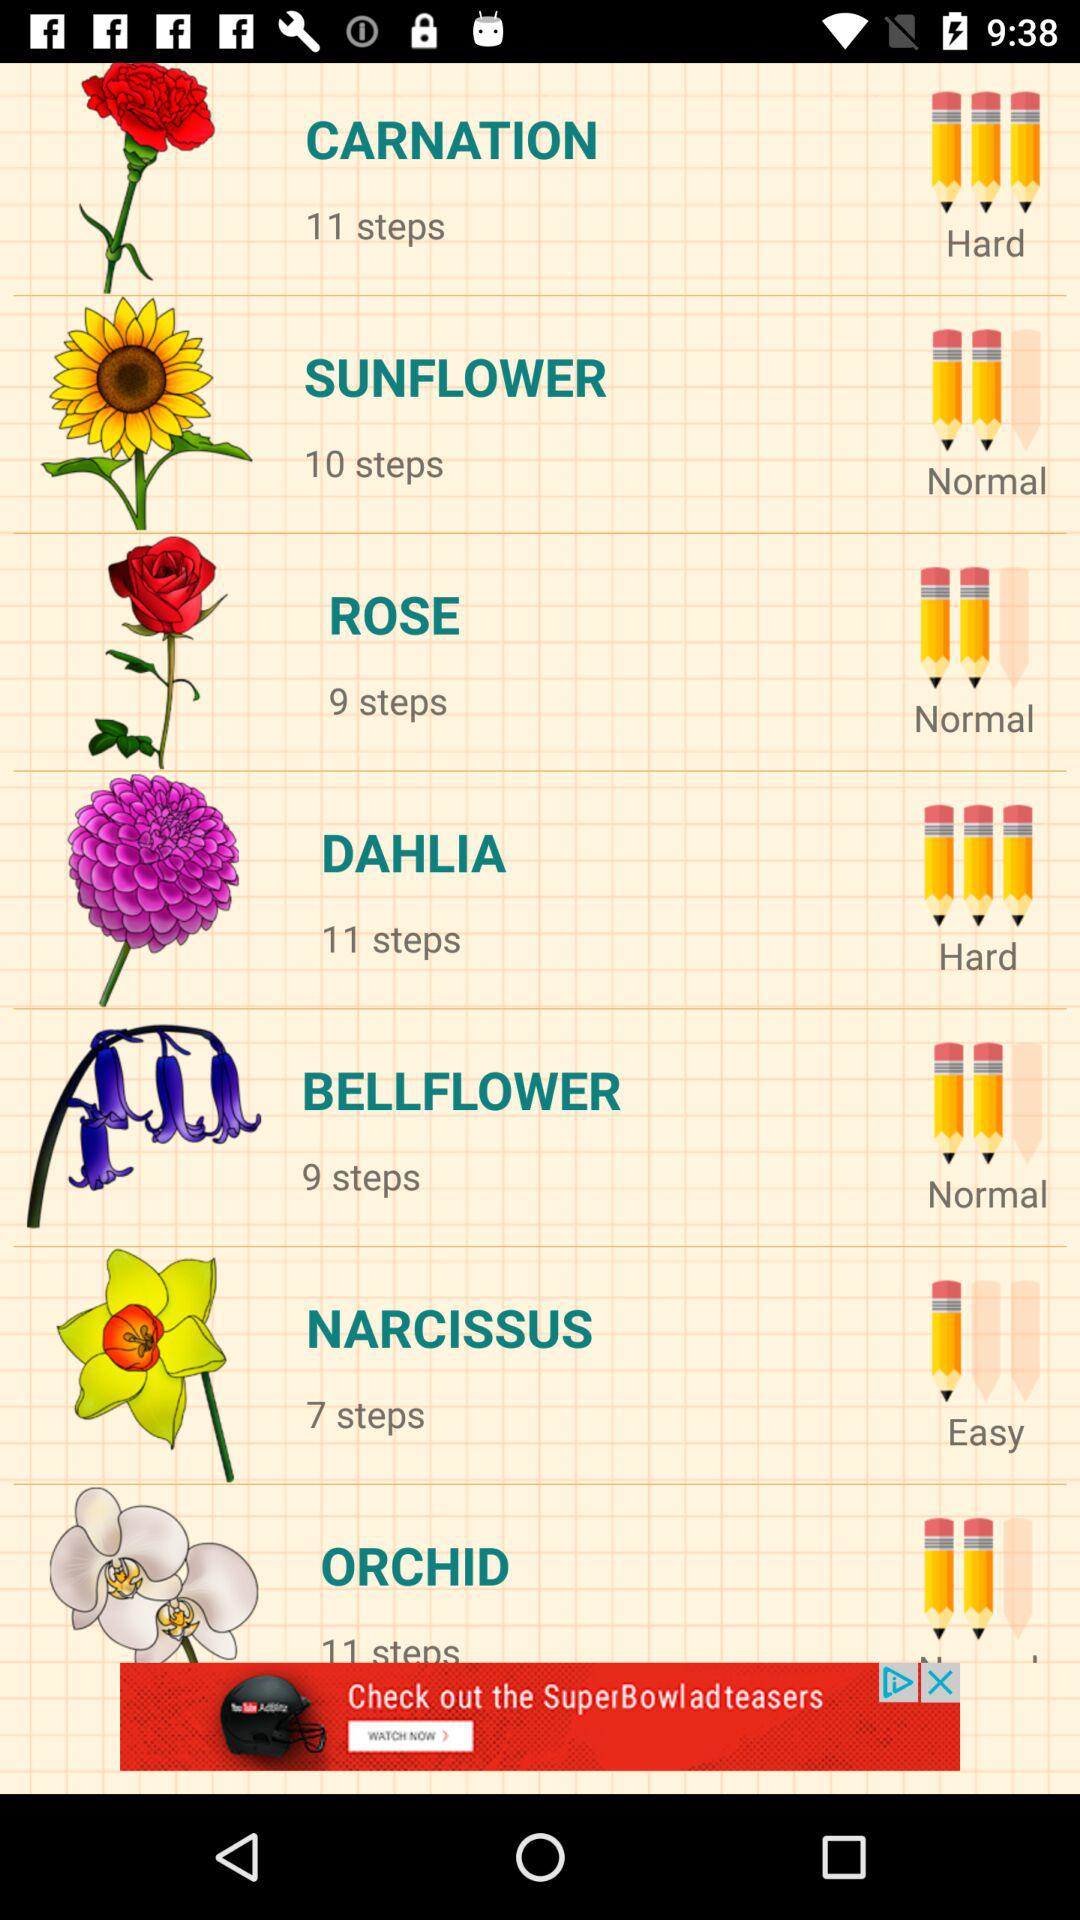Which flower requires seven steps to draw?
Answer the question using a single word or phrase. It is narcissus. 